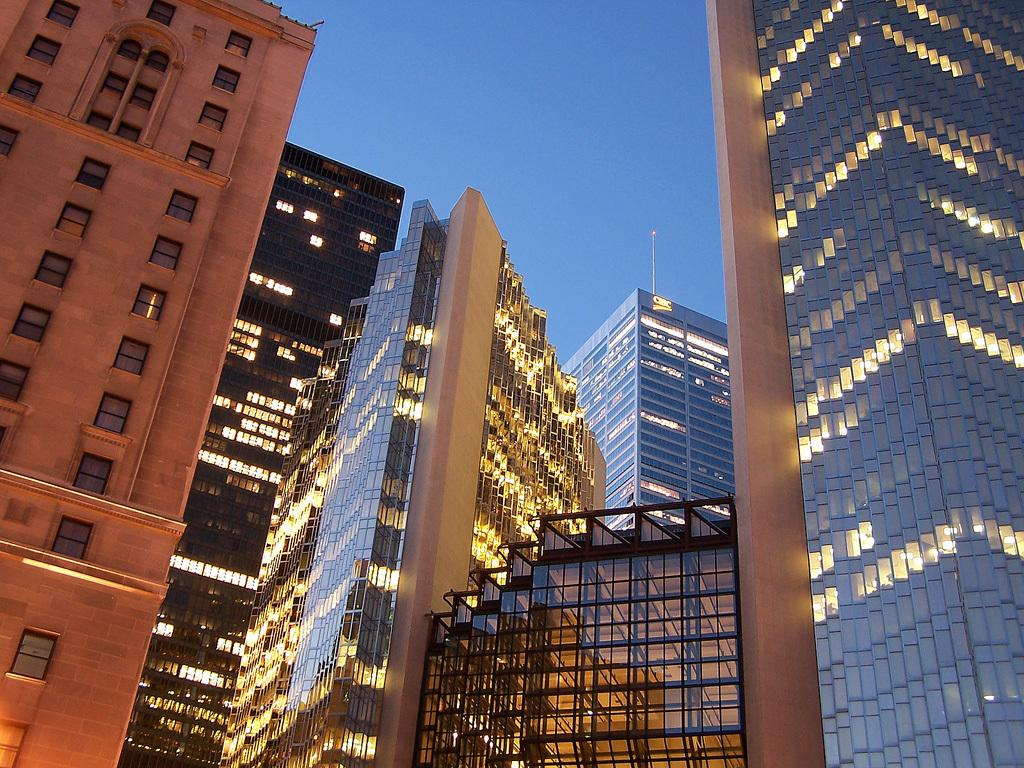What type of location is depicted in the image? The image is of a city. What are some of the prominent features of the city? There are skyscrapers and buildings in the image. What material are the windows of the buildings made of? The windows of the buildings are made of glass. What is the condition of the sky in the image? The sky is clear in the image. How many bottles of soda can be seen on the rooftops of the buildings in the image? There are no bottles of soda visible on the rooftops of the buildings in the image. What type of animals are grazing in the city in the image? There are no animals grazing in the city in the image. 